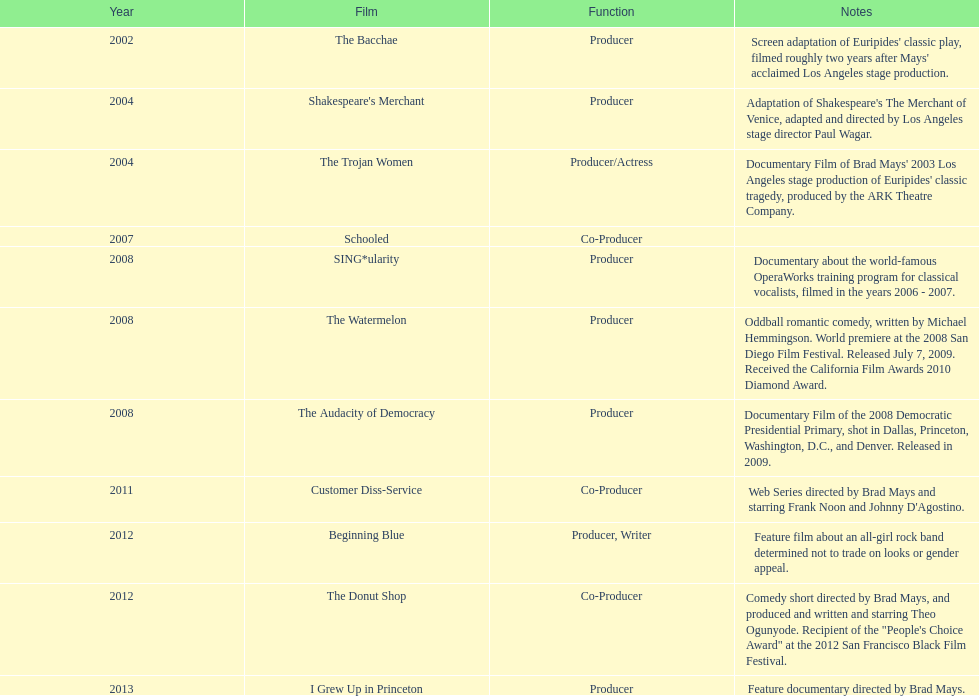How many films did ms. starfelt produce after 2010? 4. 